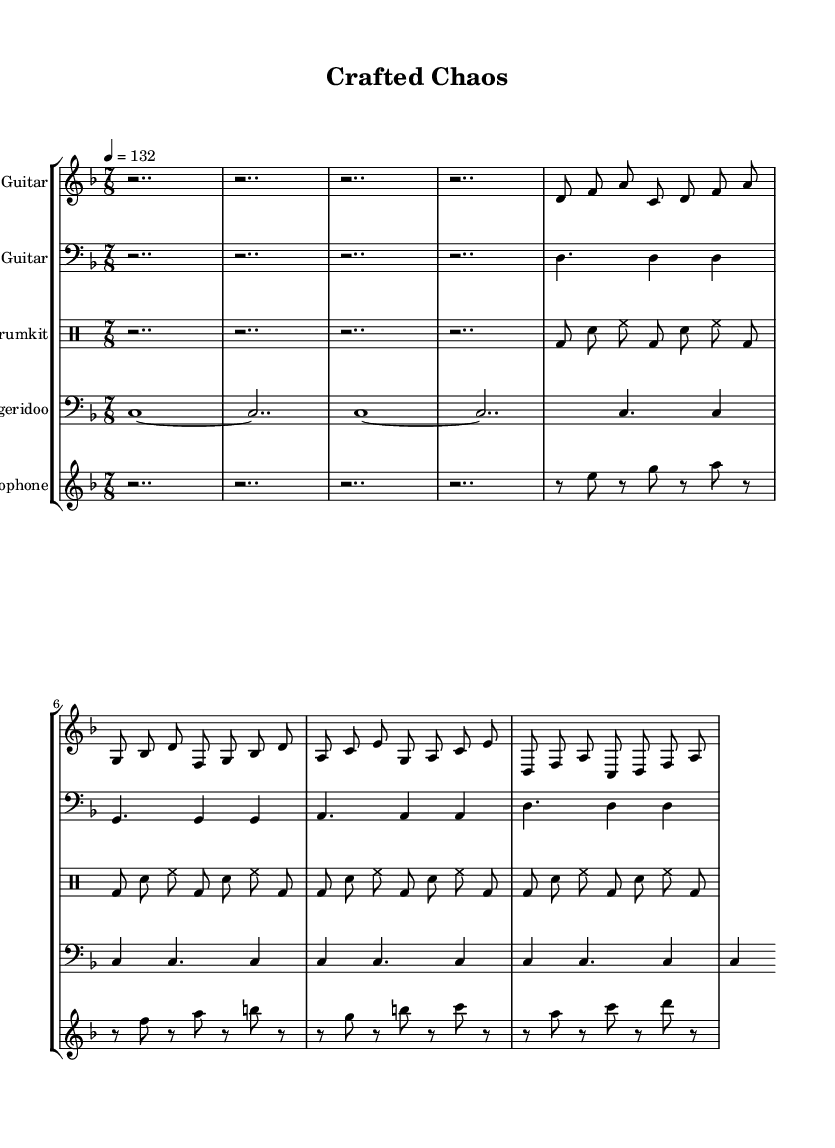What is the key signature of this music? The key signature is D minor, which is commonly represented with one flat (B flat). However, the presence of D minors indicates that pieces in this signature typically have a dark tone.
Answer: D minor What is the time signature of this music? The time signature displayed in the music is 7/8, which indicates that there are seven beats in each measure and each beat is an eighth note. This uneven meter contributes to the avant-garde feel of the piece.
Answer: 7/8 What is the tempo marking for the music? The tempo marking is indicated as 4 equals 132, meaning that there should be 132 beats per minute, creating a brisk pace for the performance.
Answer: 132 How many instruments are represented in the score? By counting the staves in the score, there are five distinct instruments listed, indicating a diverse combination of traditional and unconventional instruments.
Answer: 5 Which unconventional instrument uses craft supplies? The Craft Paper Tube Didgeridoo, which is explicitly identified in the score, is an unconventional instrument made using craft supplies. It showcases the avant-garde aspect of the composition.
Answer: Craft Paper Tube Didgeridoo Which instrument has the highest pitch? The Glass Bottle Xylophone, which appears in the treble clef and plays notes an octave higher than the Bass Guitar, indicates that it produces the highest pitch among the instruments.
Answer: Glass Bottle Xylophone What rhythmic pattern do the drums follow? The drum part exhibits a consistent pattern of bass and snare hits, with the bass drum playing on the beats and the snare accentuating the offbeats, creating a driving rhythm typical of metal music.
Answer: Bass and snare pattern 